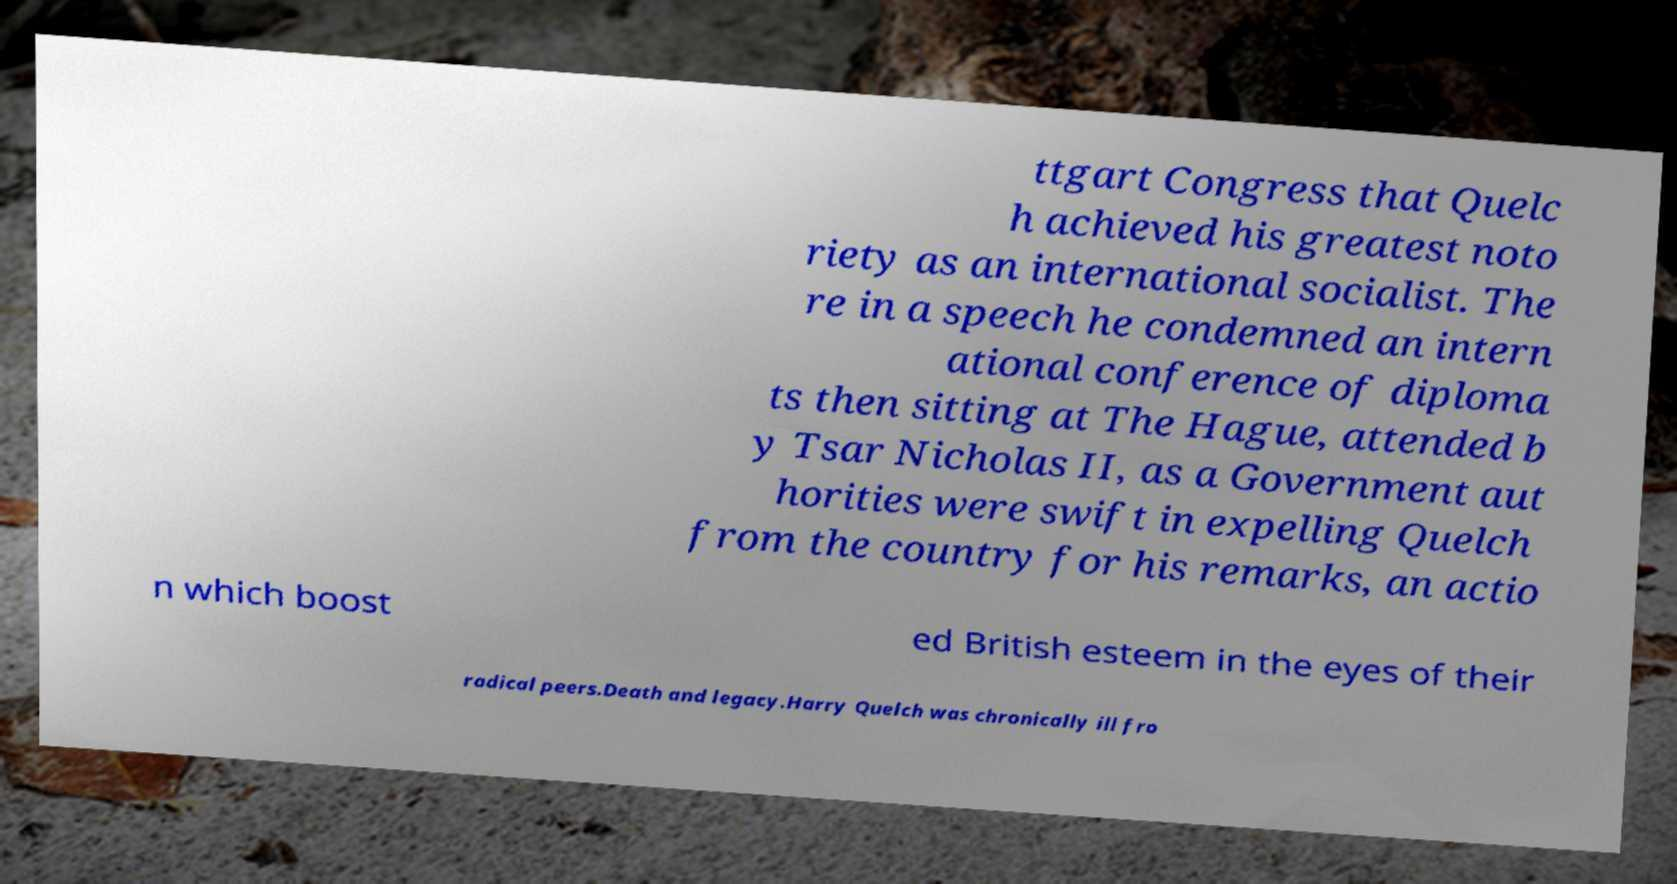Please identify and transcribe the text found in this image. ttgart Congress that Quelc h achieved his greatest noto riety as an international socialist. The re in a speech he condemned an intern ational conference of diploma ts then sitting at The Hague, attended b y Tsar Nicholas II, as a Government aut horities were swift in expelling Quelch from the country for his remarks, an actio n which boost ed British esteem in the eyes of their radical peers.Death and legacy.Harry Quelch was chronically ill fro 